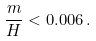<formula> <loc_0><loc_0><loc_500><loc_500>\frac { m } { H } < 0 . 0 0 6 \, .</formula> 